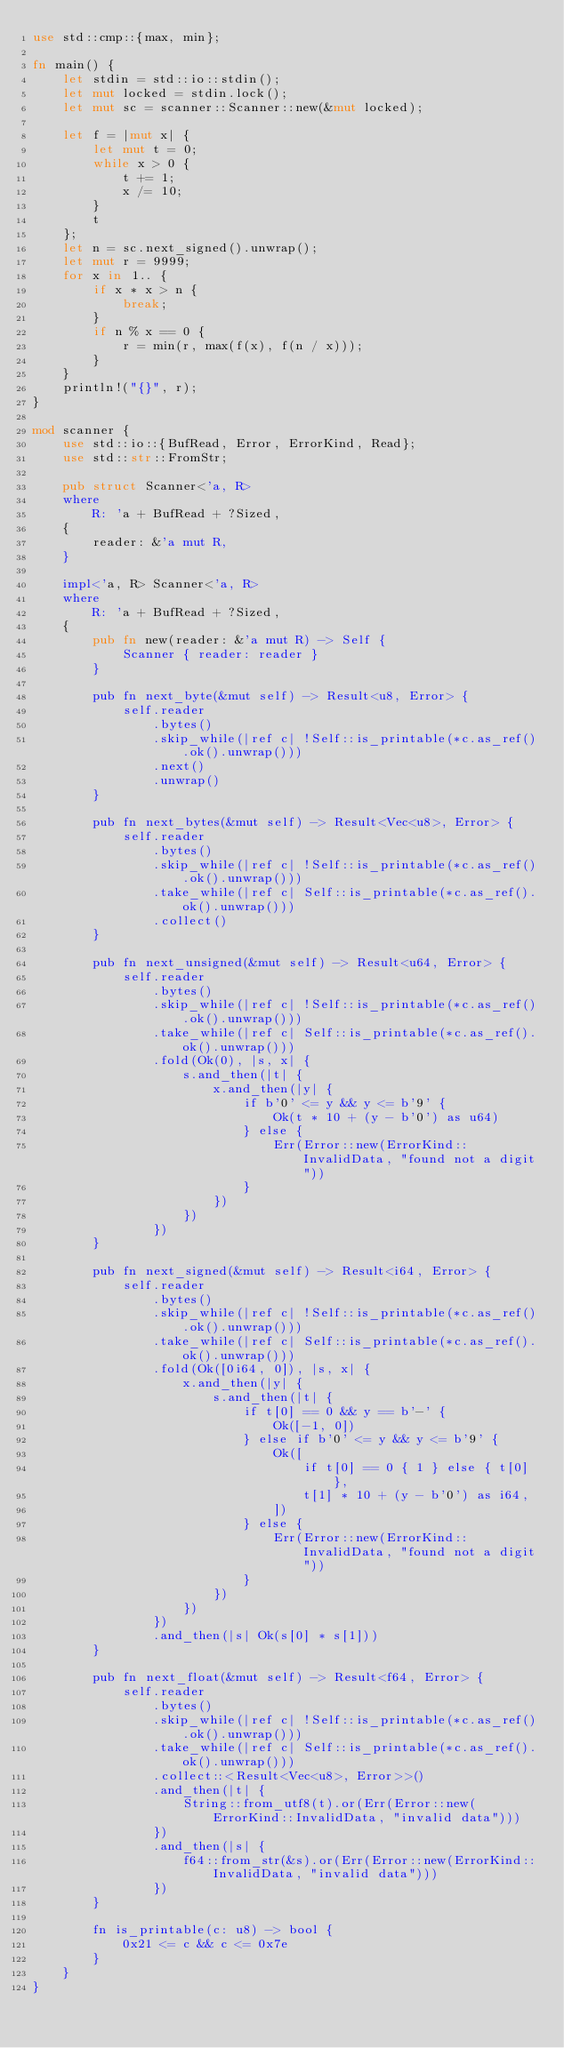<code> <loc_0><loc_0><loc_500><loc_500><_Rust_>use std::cmp::{max, min};

fn main() {
    let stdin = std::io::stdin();
    let mut locked = stdin.lock();
    let mut sc = scanner::Scanner::new(&mut locked);

    let f = |mut x| {
        let mut t = 0;
        while x > 0 {
            t += 1;
            x /= 10;
        }
        t
    };
    let n = sc.next_signed().unwrap();
    let mut r = 9999;
    for x in 1.. {
        if x * x > n {
            break;
        }
        if n % x == 0 {
            r = min(r, max(f(x), f(n / x)));
        }
    }
    println!("{}", r);
}

mod scanner {
    use std::io::{BufRead, Error, ErrorKind, Read};
    use std::str::FromStr;

    pub struct Scanner<'a, R>
    where
        R: 'a + BufRead + ?Sized,
    {
        reader: &'a mut R,
    }

    impl<'a, R> Scanner<'a, R>
    where
        R: 'a + BufRead + ?Sized,
    {
        pub fn new(reader: &'a mut R) -> Self {
            Scanner { reader: reader }
        }

        pub fn next_byte(&mut self) -> Result<u8, Error> {
            self.reader
                .bytes()
                .skip_while(|ref c| !Self::is_printable(*c.as_ref().ok().unwrap()))
                .next()
                .unwrap()
        }

        pub fn next_bytes(&mut self) -> Result<Vec<u8>, Error> {
            self.reader
                .bytes()
                .skip_while(|ref c| !Self::is_printable(*c.as_ref().ok().unwrap()))
                .take_while(|ref c| Self::is_printable(*c.as_ref().ok().unwrap()))
                .collect()
        }

        pub fn next_unsigned(&mut self) -> Result<u64, Error> {
            self.reader
                .bytes()
                .skip_while(|ref c| !Self::is_printable(*c.as_ref().ok().unwrap()))
                .take_while(|ref c| Self::is_printable(*c.as_ref().ok().unwrap()))
                .fold(Ok(0), |s, x| {
                    s.and_then(|t| {
                        x.and_then(|y| {
                            if b'0' <= y && y <= b'9' {
                                Ok(t * 10 + (y - b'0') as u64)
                            } else {
                                Err(Error::new(ErrorKind::InvalidData, "found not a digit"))
                            }
                        })
                    })
                })
        }

        pub fn next_signed(&mut self) -> Result<i64, Error> {
            self.reader
                .bytes()
                .skip_while(|ref c| !Self::is_printable(*c.as_ref().ok().unwrap()))
                .take_while(|ref c| Self::is_printable(*c.as_ref().ok().unwrap()))
                .fold(Ok([0i64, 0]), |s, x| {
                    x.and_then(|y| {
                        s.and_then(|t| {
                            if t[0] == 0 && y == b'-' {
                                Ok([-1, 0])
                            } else if b'0' <= y && y <= b'9' {
                                Ok([
                                    if t[0] == 0 { 1 } else { t[0] },
                                    t[1] * 10 + (y - b'0') as i64,
                                ])
                            } else {
                                Err(Error::new(ErrorKind::InvalidData, "found not a digit"))
                            }
                        })
                    })
                })
                .and_then(|s| Ok(s[0] * s[1]))
        }

        pub fn next_float(&mut self) -> Result<f64, Error> {
            self.reader
                .bytes()
                .skip_while(|ref c| !Self::is_printable(*c.as_ref().ok().unwrap()))
                .take_while(|ref c| Self::is_printable(*c.as_ref().ok().unwrap()))
                .collect::<Result<Vec<u8>, Error>>()
                .and_then(|t| {
                    String::from_utf8(t).or(Err(Error::new(ErrorKind::InvalidData, "invalid data")))
                })
                .and_then(|s| {
                    f64::from_str(&s).or(Err(Error::new(ErrorKind::InvalidData, "invalid data")))
                })
        }

        fn is_printable(c: u8) -> bool {
            0x21 <= c && c <= 0x7e
        }
    }
}
</code> 